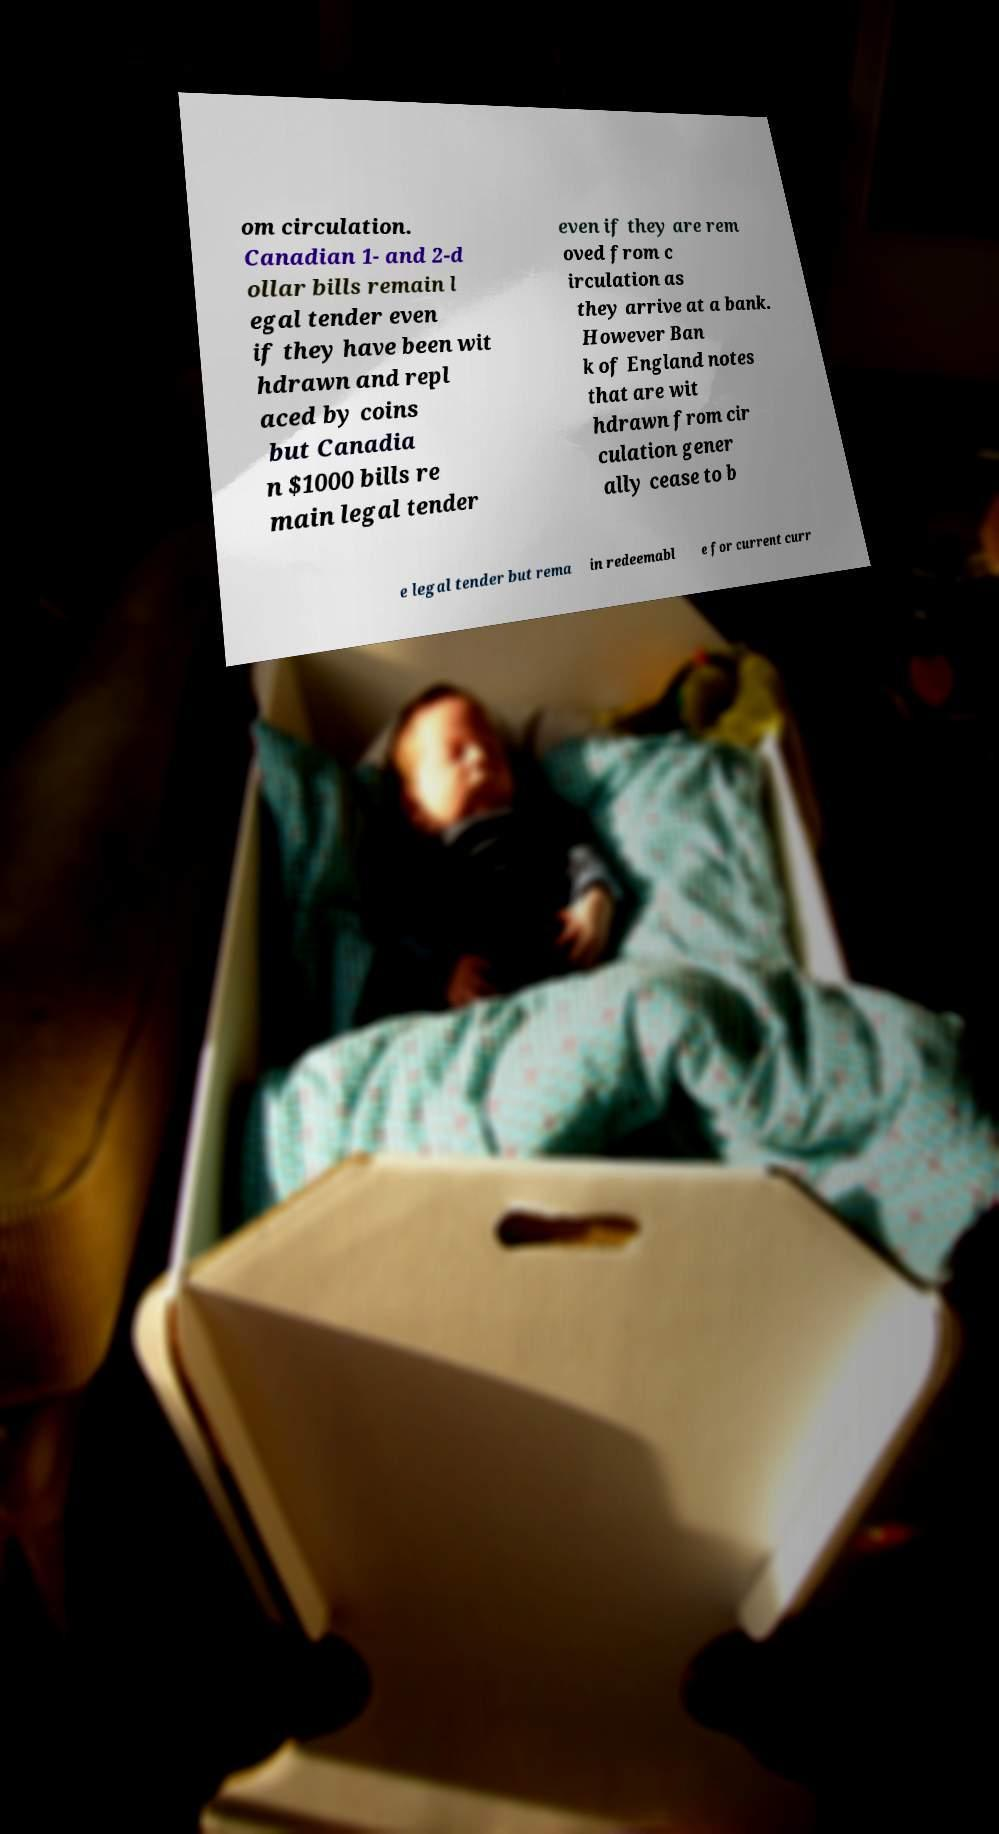Please identify and transcribe the text found in this image. om circulation. Canadian 1- and 2-d ollar bills remain l egal tender even if they have been wit hdrawn and repl aced by coins but Canadia n $1000 bills re main legal tender even if they are rem oved from c irculation as they arrive at a bank. However Ban k of England notes that are wit hdrawn from cir culation gener ally cease to b e legal tender but rema in redeemabl e for current curr 